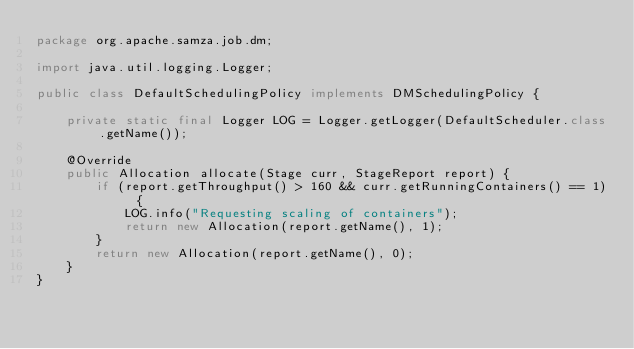Convert code to text. <code><loc_0><loc_0><loc_500><loc_500><_Java_>package org.apache.samza.job.dm;

import java.util.logging.Logger;

public class DefaultSchedulingPolicy implements DMSchedulingPolicy {

    private static final Logger LOG = Logger.getLogger(DefaultScheduler.class.getName());

    @Override
    public Allocation allocate(Stage curr, StageReport report) {
        if (report.getThroughput() > 160 && curr.getRunningContainers() == 1) {
            LOG.info("Requesting scaling of containers");
            return new Allocation(report.getName(), 1);
        }
        return new Allocation(report.getName(), 0);
    }
}
</code> 